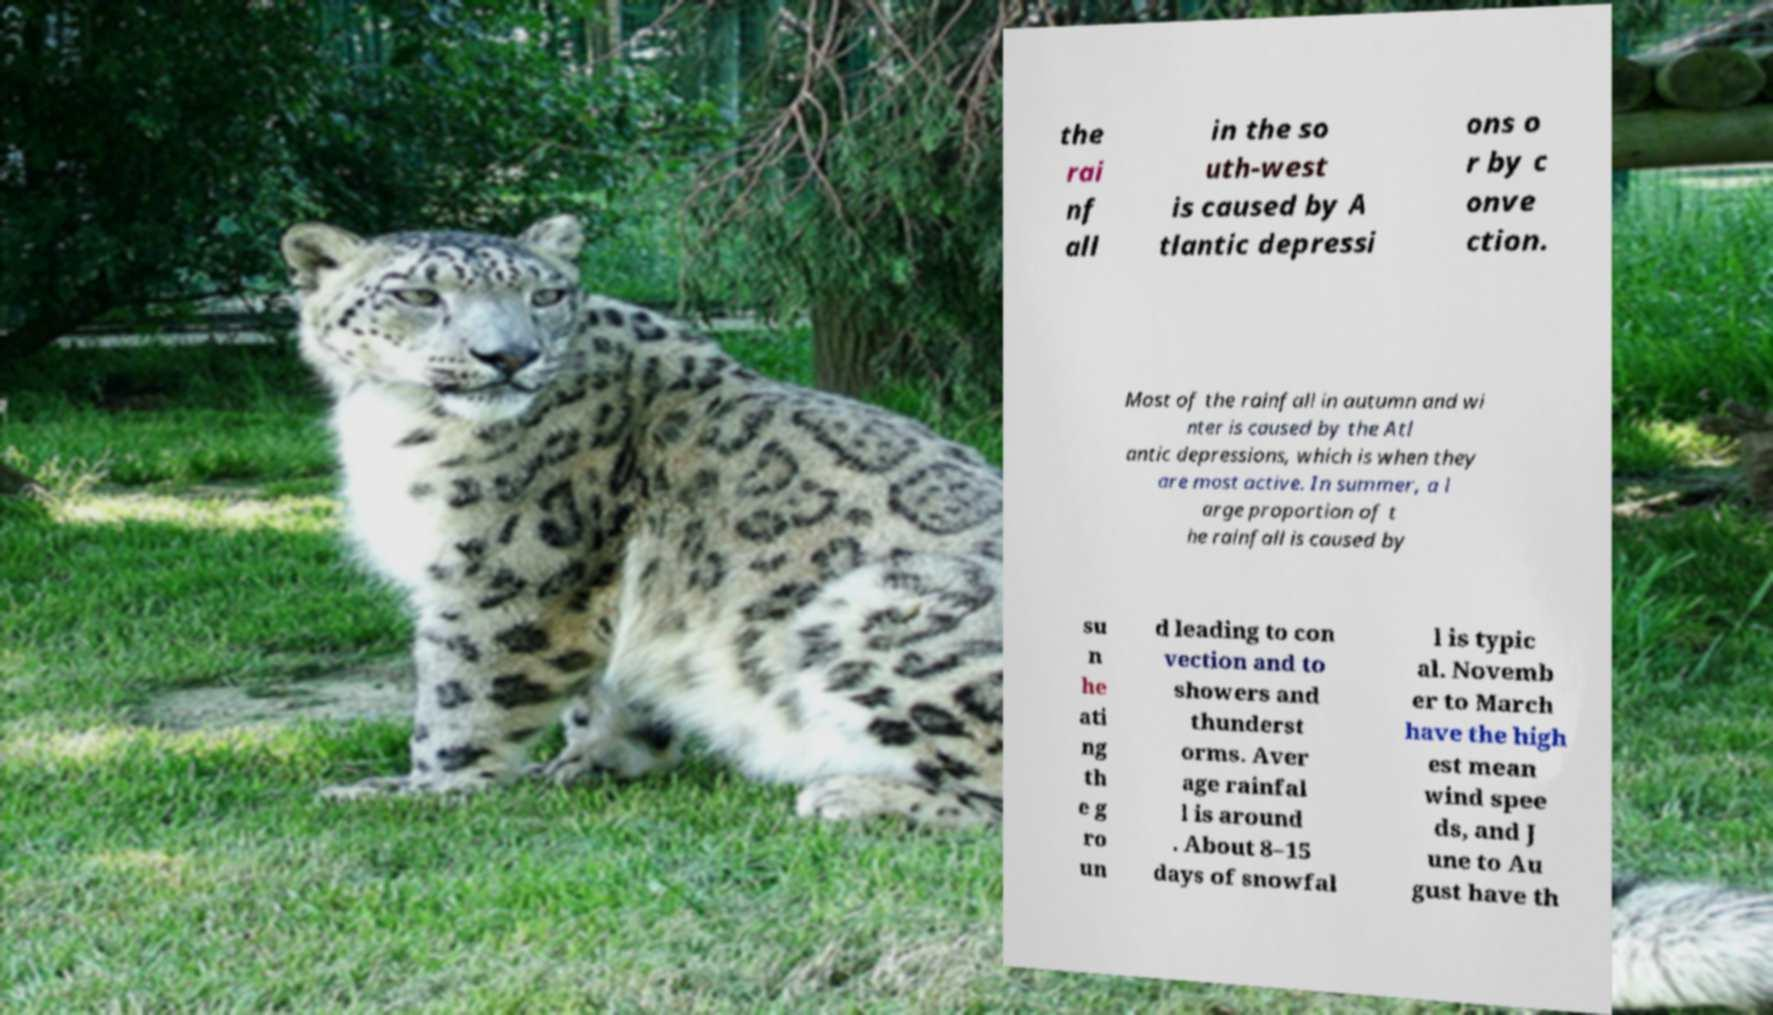Could you extract and type out the text from this image? the rai nf all in the so uth-west is caused by A tlantic depressi ons o r by c onve ction. Most of the rainfall in autumn and wi nter is caused by the Atl antic depressions, which is when they are most active. In summer, a l arge proportion of t he rainfall is caused by su n he ati ng th e g ro un d leading to con vection and to showers and thunderst orms. Aver age rainfal l is around . About 8–15 days of snowfal l is typic al. Novemb er to March have the high est mean wind spee ds, and J une to Au gust have th 